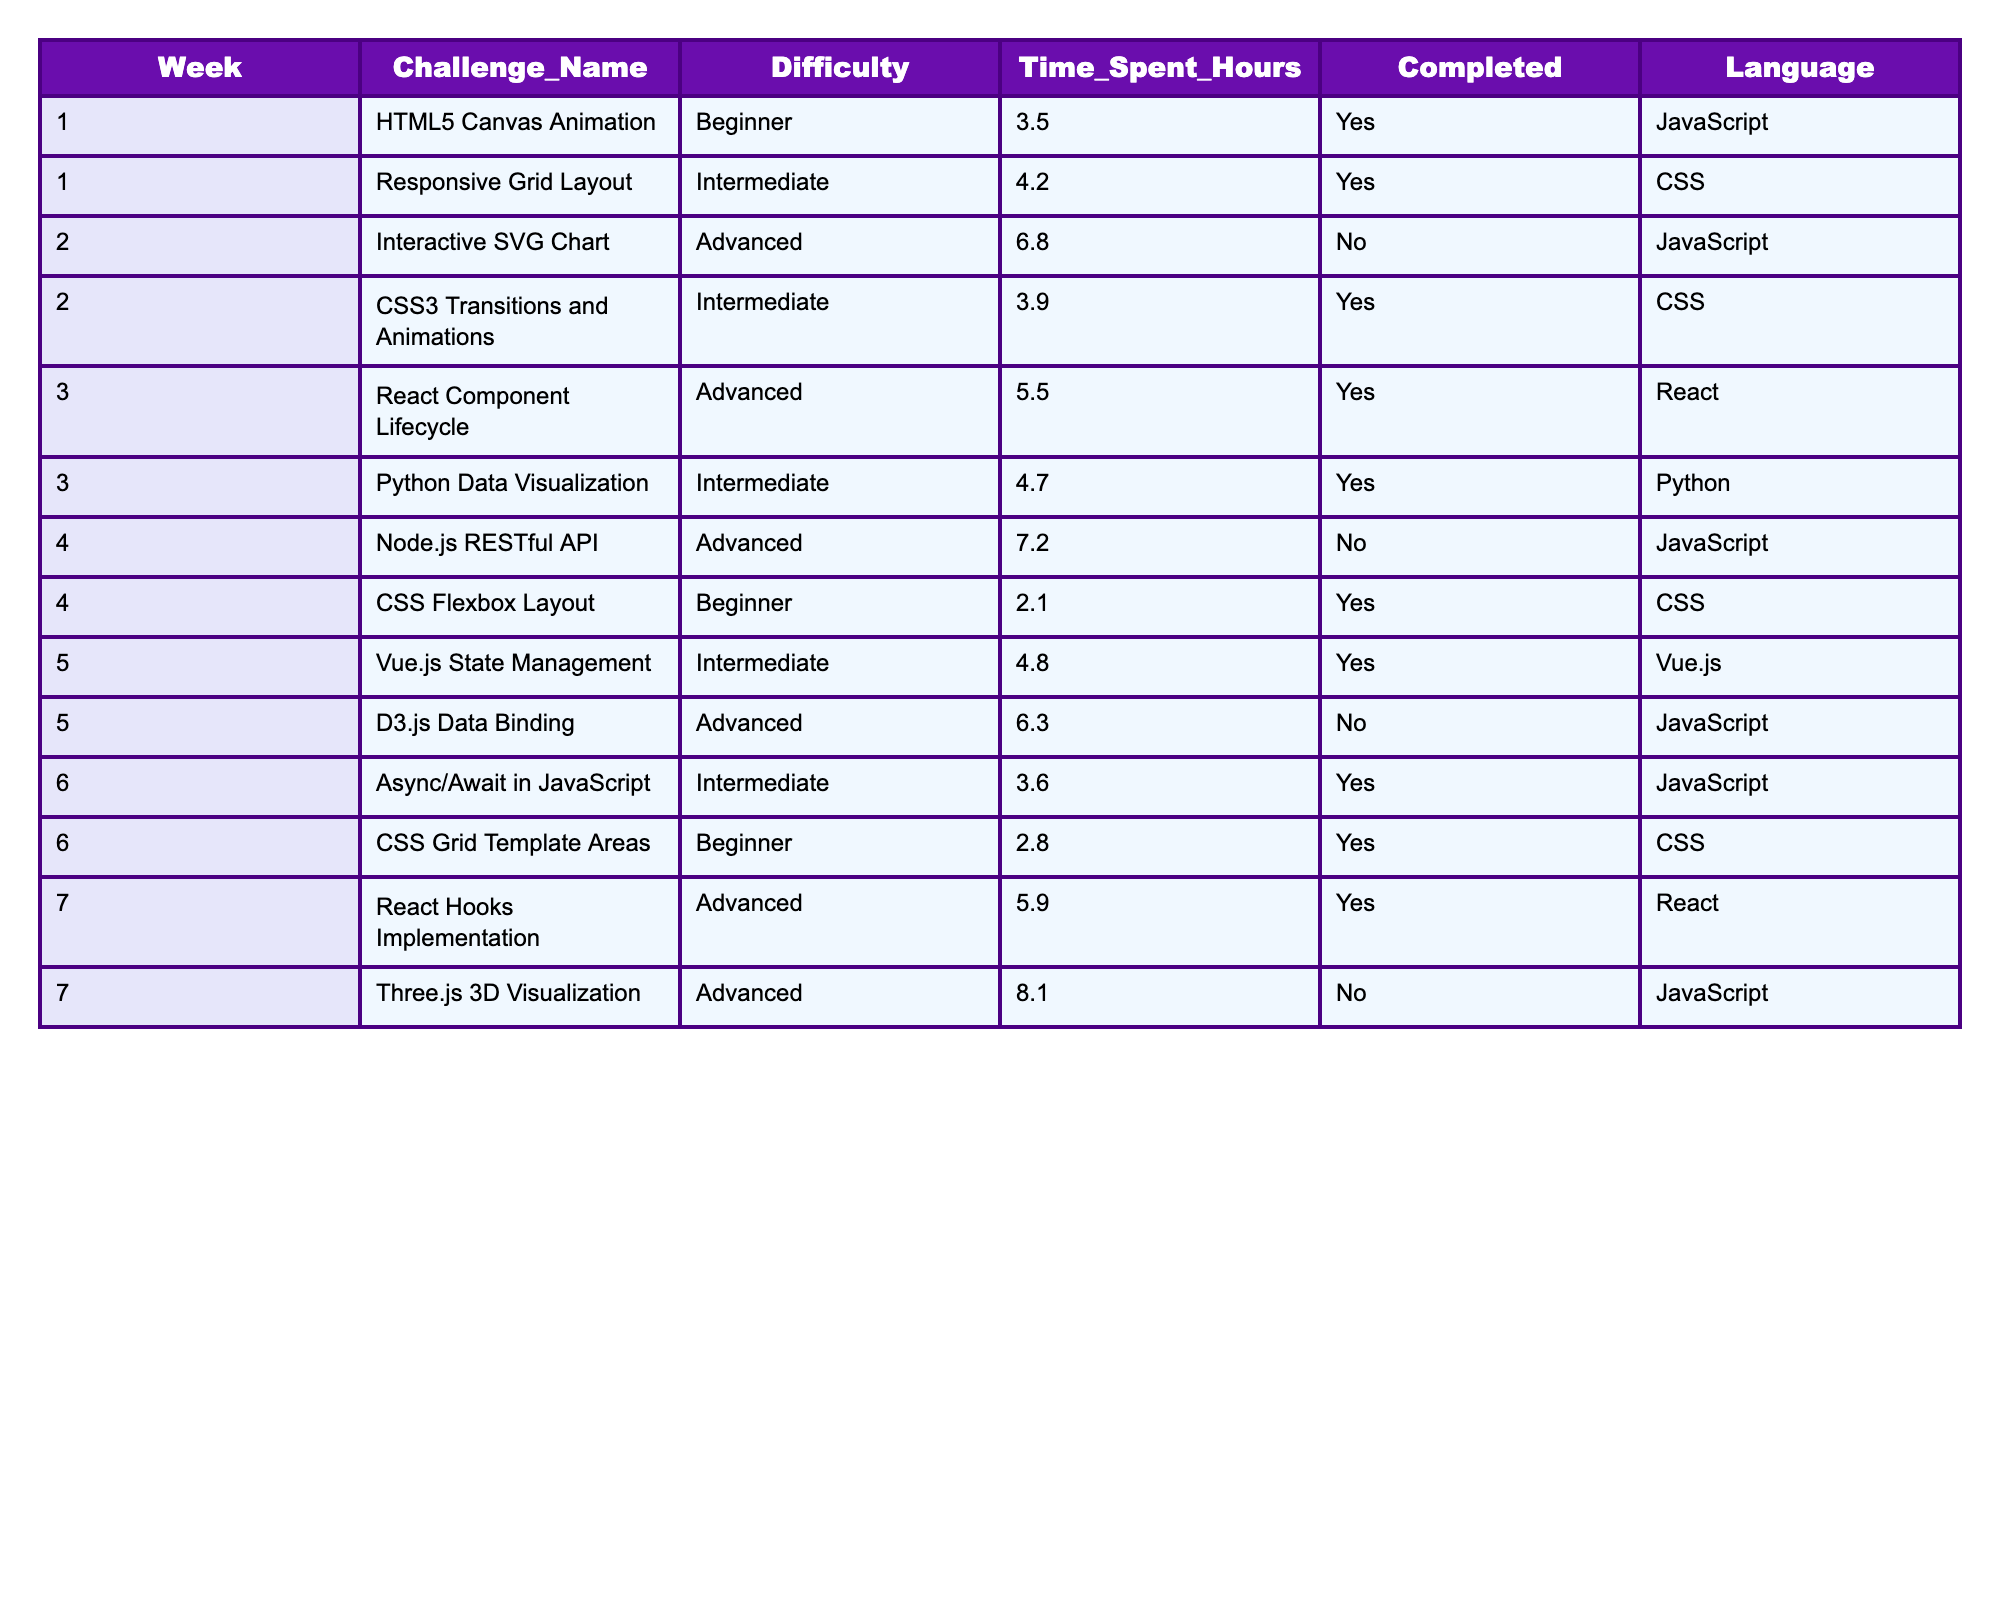What is the longest time spent on a single challenge? The maximum value in the 'Time_Spent_Hours' column is 8.1, associated with the 'Three.js 3D Visualization' challenge.
Answer: 8.1 How many challenges have been completed by the end of week 5? Count the 'Yes' values in the 'Completed' column for weeks 1 through 5, which totals 5 challenges completed.
Answer: 5 Which language has the most completed challenges? We count the 'Yes' in the 'Completed' column per language: JavaScript has 3, CSS has 4, React has 2, Python has 1, Vue.js has 1. CSS has the highest number, at 4.
Answer: CSS What is the average time spent on completed challenges? Add the time of completed challenges (3.5 + 4.2 + 5.5 + 4.7 + 4.8 + 3.6 + 5.9) = 36.2 hours over 7 challenges, giving an average of 36.2/7 ≈ 5.17 hours.
Answer: 5.17 Did any challenge with 'Advanced' difficulty get completed in week 4? Check the completed status of challenges with 'Advanced' difficulty in week 4. 'Node.js RESTful API' is marked as 'No', so the answer is no.
Answer: No How many more challenges were completed than not completed by week 6? There are 7 completed and 5 not completed challenges up to week 6. The difference is 7 - 5 = 2 more completed.
Answer: 2 What percentage of challenges in week 7 were completed? Out of the 2 challenges in week 7, 1 was completed. Thus, the percentage is (1/2)*100 = 50%.
Answer: 50 For the challenges completed, what is the most common difficulty level? The difficulties for completed challenges are: Beginner (2), Intermediate (3), Advanced (2). The most common is Intermediate with 3.
Answer: Intermediate Which week had the least completed challenges? The number of completed challenges per week are: Week 1 (2), Week 2 (1), Week 3 (2), Week 4 (1), Week 5 (2), Week 6 (2), Week 7 (1). Week 2 and Week 4 had the least with 1 each.
Answer: Week 2 and Week 4 How many coding challenges were completed in total after week 6? Count all 'Yes' in the 'Completed' column from weeks 1 to 6, which totals 7 challenges completed.
Answer: 7 